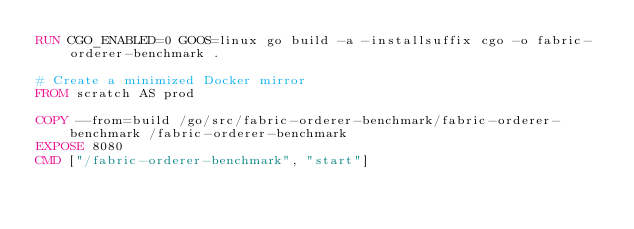<code> <loc_0><loc_0><loc_500><loc_500><_Dockerfile_>RUN CGO_ENABLED=0 GOOS=linux go build -a -installsuffix cgo -o fabric-orderer-benchmark .

# Create a minimized Docker mirror
FROM scratch AS prod

COPY --from=build /go/src/fabric-orderer-benchmark/fabric-orderer-benchmark /fabric-orderer-benchmark
EXPOSE 8080
CMD ["/fabric-orderer-benchmark", "start"]
</code> 